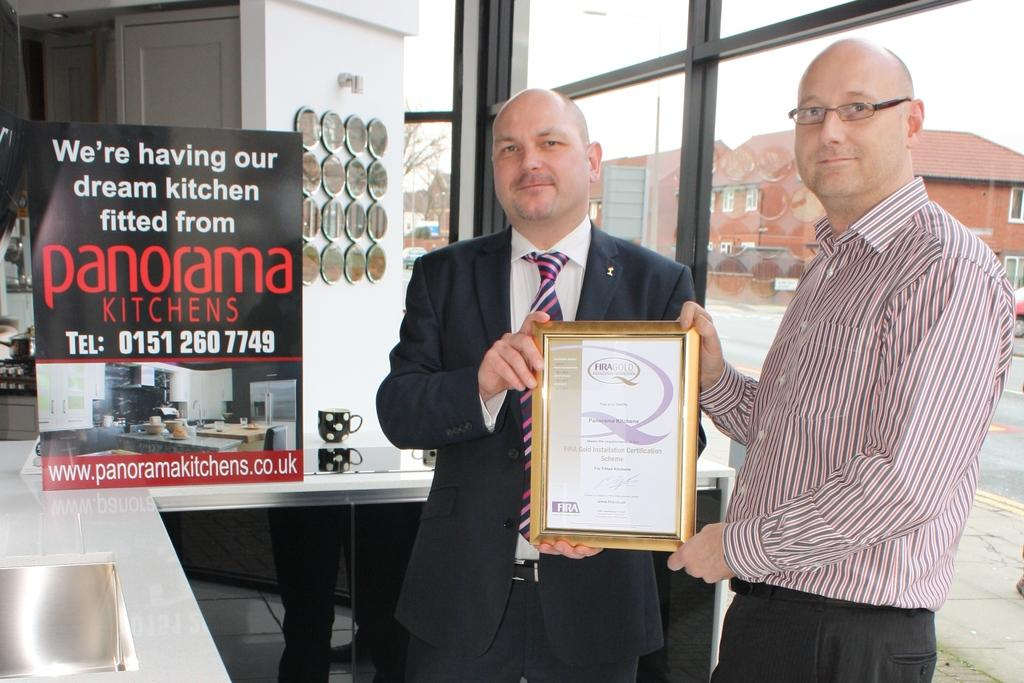Provide a one-sentence caption for the provided image. Two men stand holding an award between them and next to them is a sign that says panorama on it. 